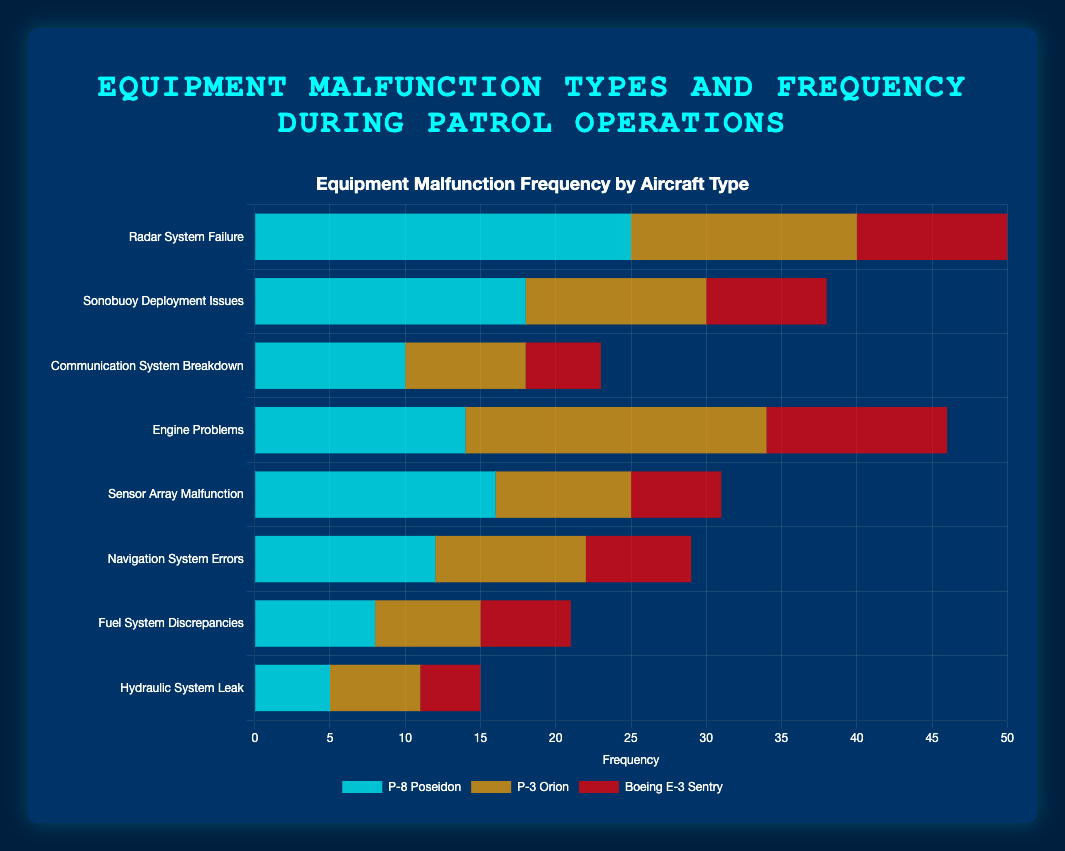Which aircraft type has the highest frequency of radar system failures? The P-8 Poseidon has the highest bar length under "Radar System Failure," followed by the P-3 Orion and the Boeing E-3 Sentry.
Answer: P-8 Poseidon Which malfunction type has the lowest total frequency across all aircraft? Summing the values for each aircraft type for all malfunction types, "Hydraulic System Leak" has the lowest total frequency.
Answer: Hydraulic System Leak Which aircraft has the highest frequency of engine problems? Looking at the "Engine Problems" category, the P-3 Orion has the highest bar length, followed by the Boeing E-3 Sentry and then the P-8 Poseidon.
Answer: P-3 Orion What is the total frequency of sonobuoy deployment issues across all aircraft? Sum the frequencies for each aircraft type under "Sonobuoy Deployment Issues": 18 (P-8 Poseidon) + 12 (P-3 Orion) + 8 (Boeing E-3 Sentry) = 38.
Answer: 38 Which malfunction type has a higher frequency in the P-3 Orion than in the other two aircraft? Comparing bar lengths across malfunction types, "Engine Problems" has the highest frequency in the P-3 Orion compared to the P-8 Poseidon and Boeing E-3 Sentry.
Answer: Engine Problems What is the frequency difference between the highest and lowest occurring malfunction types for the Boeing E-3 Sentry? The highest frequency for the Boeing E-3 Sentry is "Engine Problems" at 12 and the lowest is "Hydraulic System Leak" at 4. The difference is 12 - 4 = 8.
Answer: 8 What is the total frequency of navigation system errors across all aircraft? Sum the frequencies for each aircraft type under "Navigation System Errors": 12 (P-8 Poseidon) + 10 (P-3 Orion) + 7 (Boeing E-3 Sentry) = 29.
Answer: 29 Which aircraft has the least frequency of sensor array malfunctions? Looking at the "Sensor Array Malfunction" category, the Boeing E-3 Sentry has the smallest bar length compared to the P-8 Poseidon and P-3 Orion.
Answer: Boeing E-3 Sentry 